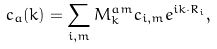Convert formula to latex. <formula><loc_0><loc_0><loc_500><loc_500>c _ { a } ( { k } ) = \sum _ { i , m } M ^ { a m } _ { k } c _ { i , m } e ^ { i { k } \cdot { R } _ { i } } ,</formula> 